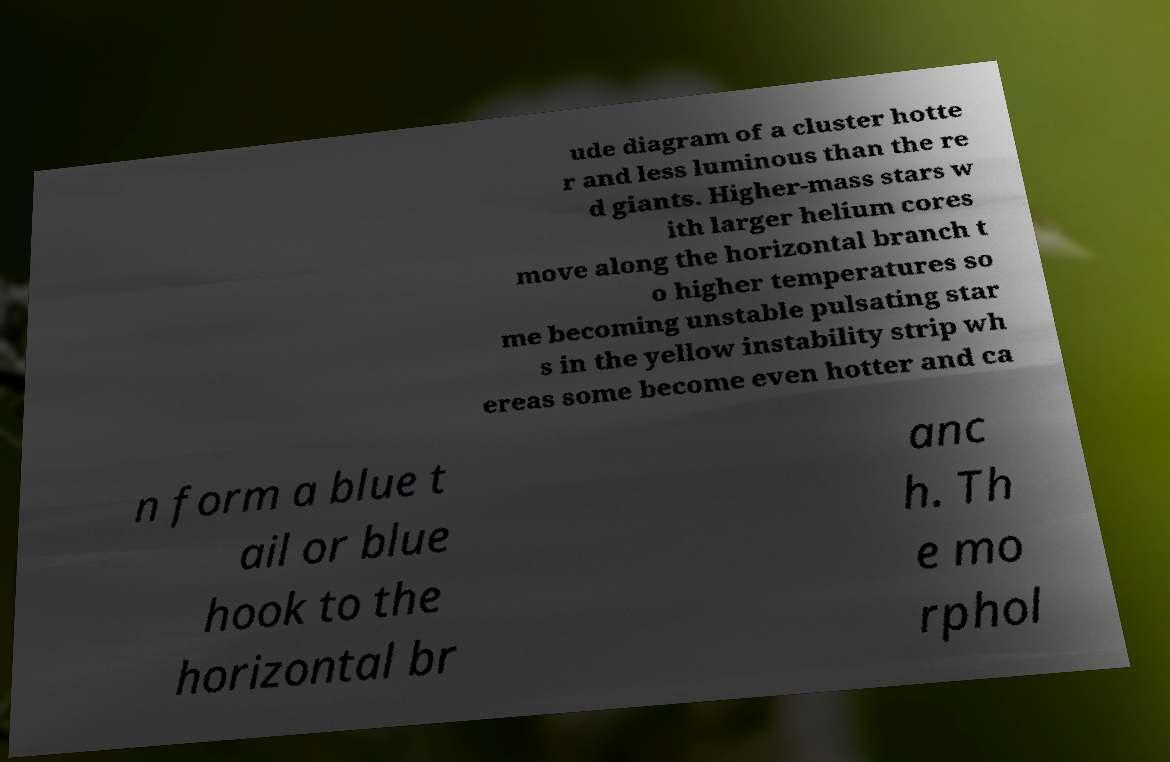Please read and relay the text visible in this image. What does it say? ude diagram of a cluster hotte r and less luminous than the re d giants. Higher-mass stars w ith larger helium cores move along the horizontal branch t o higher temperatures so me becoming unstable pulsating star s in the yellow instability strip wh ereas some become even hotter and ca n form a blue t ail or blue hook to the horizontal br anc h. Th e mo rphol 